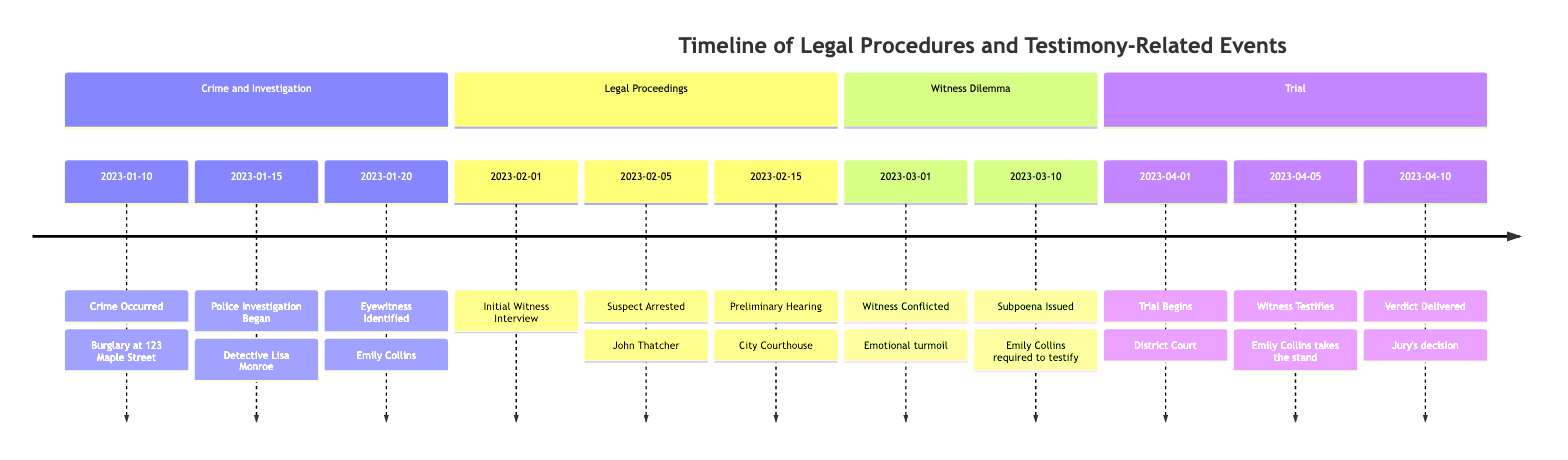What date did the crime occur? The timeline shows that the crime occurred on January 10, 2023, which is the first event listed.
Answer: January 10, 2023 Who began the police investigation? The second entry in the timeline indicates that Detective Lisa Monroe from the City Police Department started the investigation.
Answer: Detective Lisa Monroe What was the first event after the eyewitness was identified? After Emily Collins was identified as an eyewitness on January 20, 2023, the next event was her initial interview on February 1, 2023, according to the timeline.
Answer: Initial Witness Interview How long after the crime did the suspect get arrested? The crime occurred on January 10, 2023, and the suspect, John Thatcher, was arrested on February 5, 2023. This is 26 days later.
Answer: 26 days What was Emily Collins's emotional state regarding testifying? On March 1, 2023, the timeline notes that Emily Collins expressed emotional conflict about testifying against her friend, indicating a troubled emotional state.
Answer: Emotional conflict What event occurred directly before the trial began? The trial began on April 1, 2023, and the witness, Emily Collins, testified just a few days later on April 5, 2023, which is the event that comes right before the trial starts in the timeline.
Answer: Subpoena Issued What was the outcome at the end of the trial? The final event in the timeline states that on April 10, 2023, the jury delivered a verdict in the case against John Thatcher, which concludes the legal proceedings.
Answer: Verdict Delivered How many days were there between the suspect's arrest and the preliminary hearing? John Thatcher was arrested on February 5, 2023, and the preliminary hearing was held on February 15, 2023. Thus, there were 10 days between these two events.
Answer: 10 days Who was the key witness identified for the case? The timeline specifies on January 20, 2023, that Emily Collins was identified as the key eyewitness due to her presence at the crime scene.
Answer: Emily Collins 